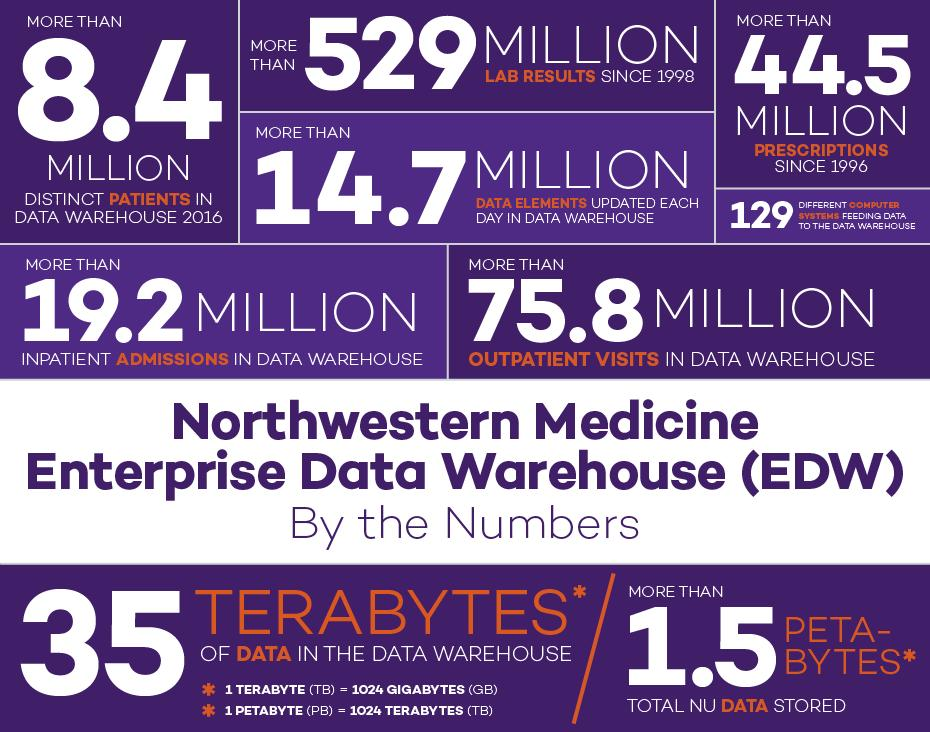List a handful of essential elements in this visual. 35 Terabytes is equal to 35,840 Gigabytes. The number of patients admitted to hospitals is 75.8 million, while the number of patients visiting the doctor is higher at 78.5 million. The number of laboratory results in the data warehouse is in the millions. It can be represented as 8.8+, 529+, or 44.5+. The value 529+ is the highest among these options. 